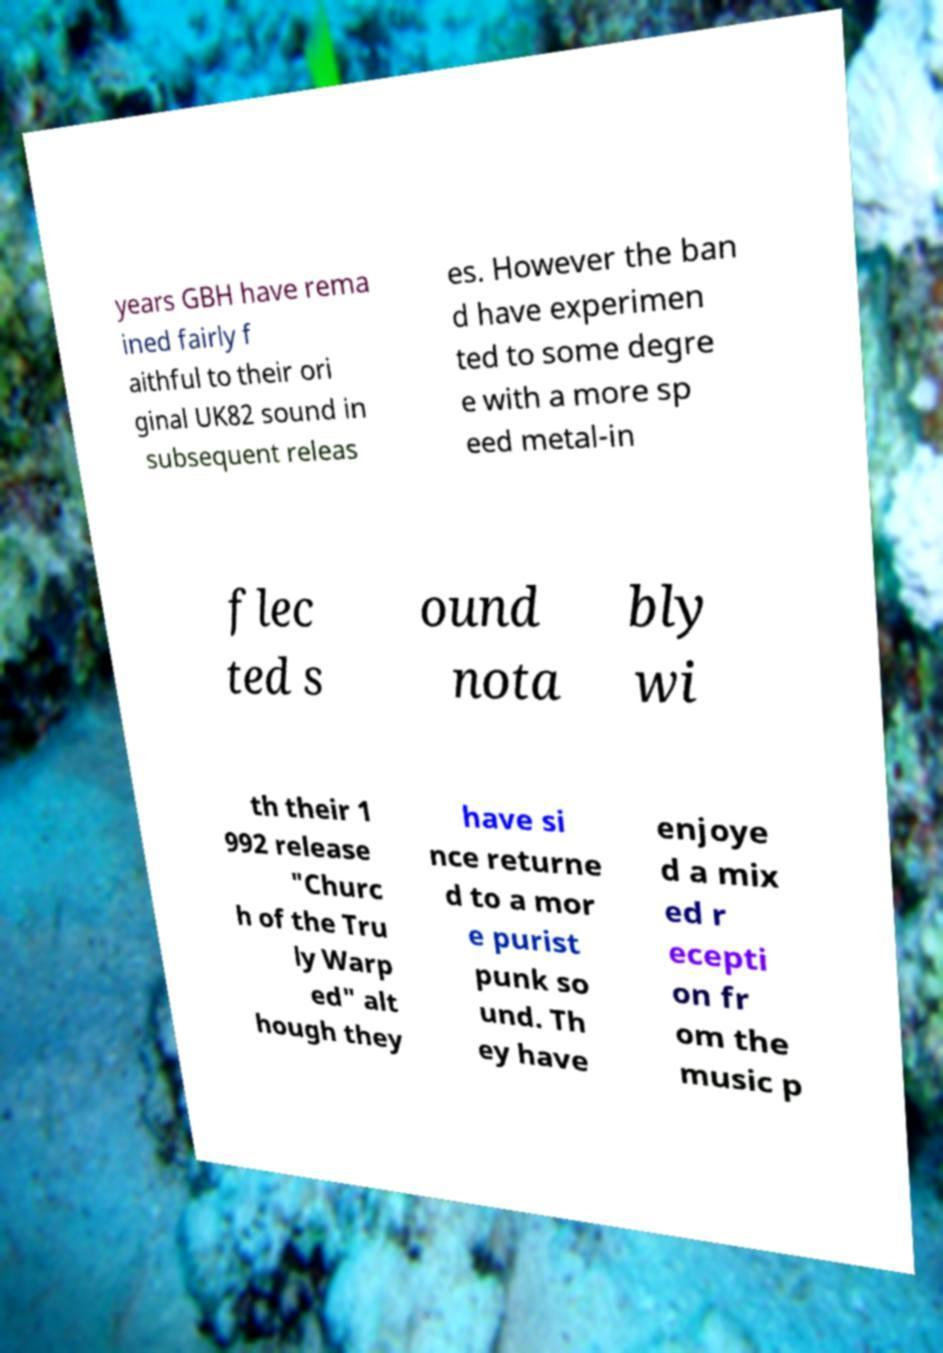What messages or text are displayed in this image? I need them in a readable, typed format. years GBH have rema ined fairly f aithful to their ori ginal UK82 sound in subsequent releas es. However the ban d have experimen ted to some degre e with a more sp eed metal-in flec ted s ound nota bly wi th their 1 992 release "Churc h of the Tru ly Warp ed" alt hough they have si nce returne d to a mor e purist punk so und. Th ey have enjoye d a mix ed r ecepti on fr om the music p 